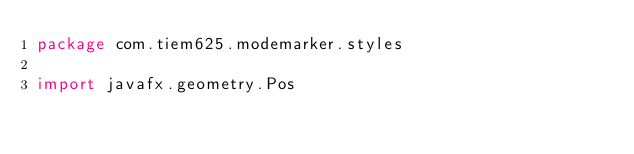Convert code to text. <code><loc_0><loc_0><loc_500><loc_500><_Kotlin_>package com.tiem625.modemarker.styles

import javafx.geometry.Pos</code> 